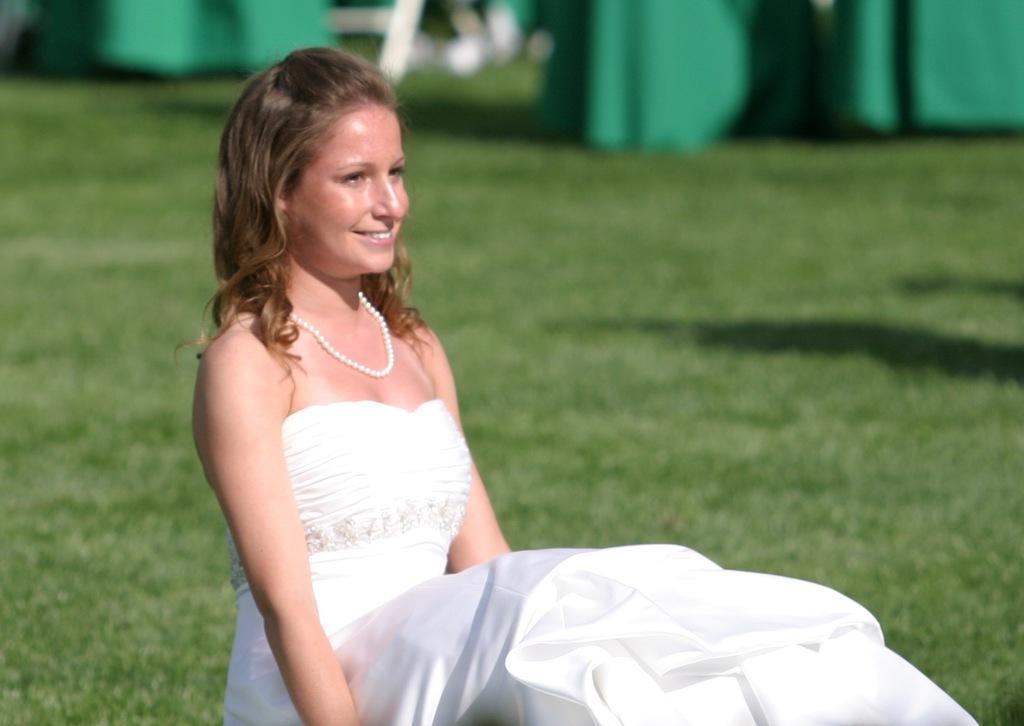How would you summarize this image in a sentence or two? In this image we can see a woman smiling. In the background we can see the grass and also some green color objects. 